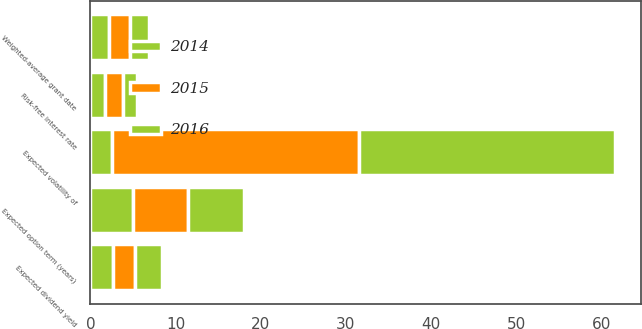Convert chart to OTSL. <chart><loc_0><loc_0><loc_500><loc_500><stacked_bar_chart><ecel><fcel>Risk-free interest rate<fcel>Expected dividend yield<fcel>Expected volatility of<fcel>Expected option term (years)<fcel>Weighted-average grant date<nl><fcel>2016<fcel>1.63<fcel>3.18<fcel>30<fcel>6.5<fcel>2.17<nl><fcel>2015<fcel>2.13<fcel>2.57<fcel>29<fcel>6.5<fcel>2.57<nl><fcel>2014<fcel>1.69<fcel>2.61<fcel>2.59<fcel>5<fcel>2.13<nl></chart> 